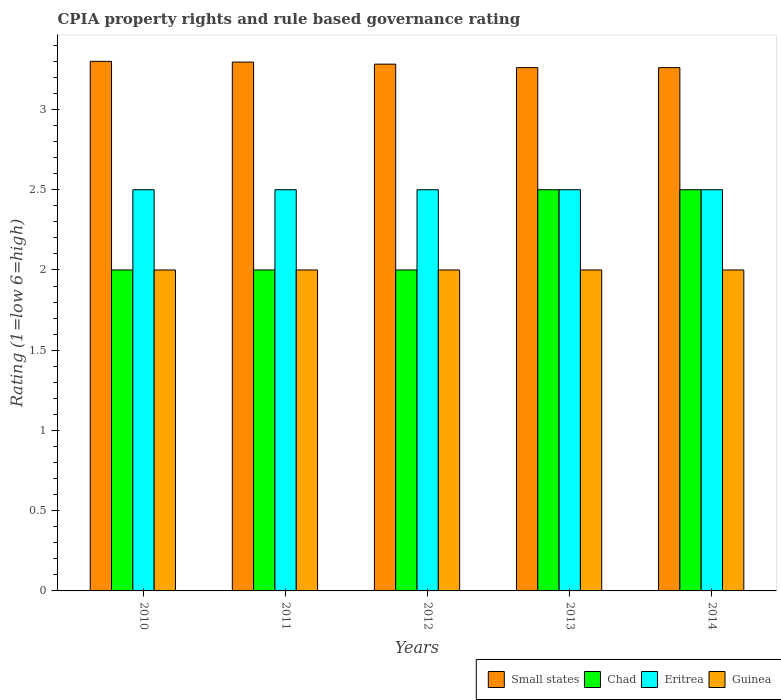How many groups of bars are there?
Your answer should be compact. 5. Are the number of bars per tick equal to the number of legend labels?
Give a very brief answer. Yes. Are the number of bars on each tick of the X-axis equal?
Keep it short and to the point. Yes. How many bars are there on the 1st tick from the right?
Ensure brevity in your answer.  4. What is the label of the 5th group of bars from the left?
Offer a very short reply. 2014. What is the CPIA rating in Small states in 2013?
Provide a succinct answer. 3.26. Across all years, what is the maximum CPIA rating in Guinea?
Provide a succinct answer. 2. In which year was the CPIA rating in Chad minimum?
Your answer should be very brief. 2010. What is the total CPIA rating in Small states in the graph?
Your response must be concise. 16.4. What is the difference between the CPIA rating in Eritrea in 2011 and that in 2013?
Provide a short and direct response. 0. In the year 2014, what is the difference between the CPIA rating in Guinea and CPIA rating in Small states?
Your answer should be compact. -1.26. Is the difference between the CPIA rating in Guinea in 2012 and 2013 greater than the difference between the CPIA rating in Small states in 2012 and 2013?
Offer a terse response. No. What is the difference between the highest and the lowest CPIA rating in Chad?
Offer a very short reply. 0.5. In how many years, is the CPIA rating in Guinea greater than the average CPIA rating in Guinea taken over all years?
Give a very brief answer. 0. Is the sum of the CPIA rating in Small states in 2012 and 2013 greater than the maximum CPIA rating in Eritrea across all years?
Keep it short and to the point. Yes. What does the 3rd bar from the left in 2012 represents?
Offer a terse response. Eritrea. What does the 1st bar from the right in 2014 represents?
Offer a very short reply. Guinea. Is it the case that in every year, the sum of the CPIA rating in Small states and CPIA rating in Eritrea is greater than the CPIA rating in Chad?
Your answer should be very brief. Yes. Does the graph contain any zero values?
Your answer should be compact. No. How many legend labels are there?
Offer a very short reply. 4. How are the legend labels stacked?
Give a very brief answer. Horizontal. What is the title of the graph?
Give a very brief answer. CPIA property rights and rule based governance rating. What is the label or title of the X-axis?
Make the answer very short. Years. What is the Rating (1=low 6=high) of Chad in 2010?
Offer a terse response. 2. What is the Rating (1=low 6=high) in Eritrea in 2010?
Provide a succinct answer. 2.5. What is the Rating (1=low 6=high) in Small states in 2011?
Offer a very short reply. 3.3. What is the Rating (1=low 6=high) in Guinea in 2011?
Provide a short and direct response. 2. What is the Rating (1=low 6=high) in Small states in 2012?
Provide a succinct answer. 3.28. What is the Rating (1=low 6=high) of Chad in 2012?
Keep it short and to the point. 2. What is the Rating (1=low 6=high) in Eritrea in 2012?
Make the answer very short. 2.5. What is the Rating (1=low 6=high) of Guinea in 2012?
Ensure brevity in your answer.  2. What is the Rating (1=low 6=high) of Small states in 2013?
Keep it short and to the point. 3.26. What is the Rating (1=low 6=high) of Eritrea in 2013?
Provide a succinct answer. 2.5. What is the Rating (1=low 6=high) in Small states in 2014?
Provide a succinct answer. 3.26. Across all years, what is the maximum Rating (1=low 6=high) of Small states?
Offer a very short reply. 3.3. Across all years, what is the maximum Rating (1=low 6=high) of Chad?
Ensure brevity in your answer.  2.5. Across all years, what is the maximum Rating (1=low 6=high) in Guinea?
Offer a very short reply. 2. Across all years, what is the minimum Rating (1=low 6=high) of Small states?
Your answer should be very brief. 3.26. Across all years, what is the minimum Rating (1=low 6=high) in Chad?
Ensure brevity in your answer.  2. Across all years, what is the minimum Rating (1=low 6=high) in Eritrea?
Offer a terse response. 2.5. Across all years, what is the minimum Rating (1=low 6=high) in Guinea?
Your answer should be very brief. 2. What is the total Rating (1=low 6=high) of Small states in the graph?
Give a very brief answer. 16.4. What is the total Rating (1=low 6=high) in Chad in the graph?
Your answer should be very brief. 11. What is the total Rating (1=low 6=high) in Eritrea in the graph?
Offer a terse response. 12.5. What is the difference between the Rating (1=low 6=high) in Small states in 2010 and that in 2011?
Provide a short and direct response. 0. What is the difference between the Rating (1=low 6=high) in Guinea in 2010 and that in 2011?
Give a very brief answer. 0. What is the difference between the Rating (1=low 6=high) of Small states in 2010 and that in 2012?
Your response must be concise. 0.02. What is the difference between the Rating (1=low 6=high) in Chad in 2010 and that in 2012?
Make the answer very short. 0. What is the difference between the Rating (1=low 6=high) of Guinea in 2010 and that in 2012?
Ensure brevity in your answer.  0. What is the difference between the Rating (1=low 6=high) of Small states in 2010 and that in 2013?
Offer a very short reply. 0.04. What is the difference between the Rating (1=low 6=high) of Guinea in 2010 and that in 2013?
Your answer should be compact. 0. What is the difference between the Rating (1=low 6=high) in Small states in 2010 and that in 2014?
Keep it short and to the point. 0.04. What is the difference between the Rating (1=low 6=high) of Guinea in 2010 and that in 2014?
Make the answer very short. 0. What is the difference between the Rating (1=low 6=high) of Small states in 2011 and that in 2012?
Give a very brief answer. 0.01. What is the difference between the Rating (1=low 6=high) in Eritrea in 2011 and that in 2012?
Keep it short and to the point. 0. What is the difference between the Rating (1=low 6=high) in Small states in 2011 and that in 2013?
Make the answer very short. 0.03. What is the difference between the Rating (1=low 6=high) of Guinea in 2011 and that in 2013?
Ensure brevity in your answer.  0. What is the difference between the Rating (1=low 6=high) of Small states in 2011 and that in 2014?
Offer a terse response. 0.03. What is the difference between the Rating (1=low 6=high) of Guinea in 2011 and that in 2014?
Your answer should be very brief. 0. What is the difference between the Rating (1=low 6=high) in Small states in 2012 and that in 2013?
Give a very brief answer. 0.02. What is the difference between the Rating (1=low 6=high) in Chad in 2012 and that in 2013?
Keep it short and to the point. -0.5. What is the difference between the Rating (1=low 6=high) in Guinea in 2012 and that in 2013?
Ensure brevity in your answer.  0. What is the difference between the Rating (1=low 6=high) in Small states in 2012 and that in 2014?
Offer a terse response. 0.02. What is the difference between the Rating (1=low 6=high) in Guinea in 2012 and that in 2014?
Provide a succinct answer. 0. What is the difference between the Rating (1=low 6=high) in Small states in 2013 and that in 2014?
Provide a succinct answer. 0. What is the difference between the Rating (1=low 6=high) in Eritrea in 2013 and that in 2014?
Provide a succinct answer. 0. What is the difference between the Rating (1=low 6=high) in Guinea in 2013 and that in 2014?
Make the answer very short. 0. What is the difference between the Rating (1=low 6=high) of Chad in 2010 and the Rating (1=low 6=high) of Eritrea in 2011?
Provide a short and direct response. -0.5. What is the difference between the Rating (1=low 6=high) of Chad in 2010 and the Rating (1=low 6=high) of Guinea in 2011?
Provide a succinct answer. 0. What is the difference between the Rating (1=low 6=high) in Eritrea in 2010 and the Rating (1=low 6=high) in Guinea in 2011?
Your answer should be very brief. 0.5. What is the difference between the Rating (1=low 6=high) of Small states in 2010 and the Rating (1=low 6=high) of Chad in 2012?
Give a very brief answer. 1.3. What is the difference between the Rating (1=low 6=high) in Small states in 2010 and the Rating (1=low 6=high) in Eritrea in 2013?
Keep it short and to the point. 0.8. What is the difference between the Rating (1=low 6=high) in Chad in 2010 and the Rating (1=low 6=high) in Eritrea in 2013?
Provide a short and direct response. -0.5. What is the difference between the Rating (1=low 6=high) of Chad in 2010 and the Rating (1=low 6=high) of Guinea in 2013?
Provide a succinct answer. 0. What is the difference between the Rating (1=low 6=high) of Eritrea in 2010 and the Rating (1=low 6=high) of Guinea in 2013?
Your answer should be very brief. 0.5. What is the difference between the Rating (1=low 6=high) of Small states in 2010 and the Rating (1=low 6=high) of Chad in 2014?
Your response must be concise. 0.8. What is the difference between the Rating (1=low 6=high) of Small states in 2010 and the Rating (1=low 6=high) of Guinea in 2014?
Give a very brief answer. 1.3. What is the difference between the Rating (1=low 6=high) in Chad in 2010 and the Rating (1=low 6=high) in Guinea in 2014?
Make the answer very short. 0. What is the difference between the Rating (1=low 6=high) of Small states in 2011 and the Rating (1=low 6=high) of Chad in 2012?
Your answer should be very brief. 1.3. What is the difference between the Rating (1=low 6=high) of Small states in 2011 and the Rating (1=low 6=high) of Eritrea in 2012?
Offer a very short reply. 0.8. What is the difference between the Rating (1=low 6=high) of Small states in 2011 and the Rating (1=low 6=high) of Guinea in 2012?
Offer a very short reply. 1.3. What is the difference between the Rating (1=low 6=high) in Chad in 2011 and the Rating (1=low 6=high) in Eritrea in 2012?
Your response must be concise. -0.5. What is the difference between the Rating (1=low 6=high) of Chad in 2011 and the Rating (1=low 6=high) of Guinea in 2012?
Your answer should be very brief. 0. What is the difference between the Rating (1=low 6=high) in Small states in 2011 and the Rating (1=low 6=high) in Chad in 2013?
Offer a very short reply. 0.8. What is the difference between the Rating (1=low 6=high) of Small states in 2011 and the Rating (1=low 6=high) of Eritrea in 2013?
Make the answer very short. 0.8. What is the difference between the Rating (1=low 6=high) in Small states in 2011 and the Rating (1=low 6=high) in Guinea in 2013?
Ensure brevity in your answer.  1.3. What is the difference between the Rating (1=low 6=high) in Small states in 2011 and the Rating (1=low 6=high) in Chad in 2014?
Provide a succinct answer. 0.8. What is the difference between the Rating (1=low 6=high) of Small states in 2011 and the Rating (1=low 6=high) of Eritrea in 2014?
Provide a succinct answer. 0.8. What is the difference between the Rating (1=low 6=high) in Small states in 2011 and the Rating (1=low 6=high) in Guinea in 2014?
Offer a very short reply. 1.3. What is the difference between the Rating (1=low 6=high) of Eritrea in 2011 and the Rating (1=low 6=high) of Guinea in 2014?
Make the answer very short. 0.5. What is the difference between the Rating (1=low 6=high) in Small states in 2012 and the Rating (1=low 6=high) in Chad in 2013?
Provide a short and direct response. 0.78. What is the difference between the Rating (1=low 6=high) in Small states in 2012 and the Rating (1=low 6=high) in Eritrea in 2013?
Offer a very short reply. 0.78. What is the difference between the Rating (1=low 6=high) in Small states in 2012 and the Rating (1=low 6=high) in Guinea in 2013?
Keep it short and to the point. 1.28. What is the difference between the Rating (1=low 6=high) in Chad in 2012 and the Rating (1=low 6=high) in Eritrea in 2013?
Make the answer very short. -0.5. What is the difference between the Rating (1=low 6=high) in Chad in 2012 and the Rating (1=low 6=high) in Guinea in 2013?
Offer a terse response. 0. What is the difference between the Rating (1=low 6=high) in Small states in 2012 and the Rating (1=low 6=high) in Chad in 2014?
Ensure brevity in your answer.  0.78. What is the difference between the Rating (1=low 6=high) of Small states in 2012 and the Rating (1=low 6=high) of Eritrea in 2014?
Give a very brief answer. 0.78. What is the difference between the Rating (1=low 6=high) of Small states in 2012 and the Rating (1=low 6=high) of Guinea in 2014?
Your answer should be very brief. 1.28. What is the difference between the Rating (1=low 6=high) in Chad in 2012 and the Rating (1=low 6=high) in Guinea in 2014?
Provide a succinct answer. 0. What is the difference between the Rating (1=low 6=high) in Eritrea in 2012 and the Rating (1=low 6=high) in Guinea in 2014?
Make the answer very short. 0.5. What is the difference between the Rating (1=low 6=high) of Small states in 2013 and the Rating (1=low 6=high) of Chad in 2014?
Offer a very short reply. 0.76. What is the difference between the Rating (1=low 6=high) in Small states in 2013 and the Rating (1=low 6=high) in Eritrea in 2014?
Your answer should be very brief. 0.76. What is the difference between the Rating (1=low 6=high) of Small states in 2013 and the Rating (1=low 6=high) of Guinea in 2014?
Your response must be concise. 1.26. What is the difference between the Rating (1=low 6=high) of Chad in 2013 and the Rating (1=low 6=high) of Guinea in 2014?
Your answer should be compact. 0.5. What is the difference between the Rating (1=low 6=high) of Eritrea in 2013 and the Rating (1=low 6=high) of Guinea in 2014?
Make the answer very short. 0.5. What is the average Rating (1=low 6=high) in Small states per year?
Offer a terse response. 3.28. What is the average Rating (1=low 6=high) in Eritrea per year?
Your answer should be very brief. 2.5. In the year 2010, what is the difference between the Rating (1=low 6=high) in Small states and Rating (1=low 6=high) in Chad?
Make the answer very short. 1.3. In the year 2010, what is the difference between the Rating (1=low 6=high) of Small states and Rating (1=low 6=high) of Eritrea?
Offer a terse response. 0.8. In the year 2010, what is the difference between the Rating (1=low 6=high) in Small states and Rating (1=low 6=high) in Guinea?
Your answer should be compact. 1.3. In the year 2010, what is the difference between the Rating (1=low 6=high) of Chad and Rating (1=low 6=high) of Eritrea?
Offer a very short reply. -0.5. In the year 2010, what is the difference between the Rating (1=low 6=high) in Chad and Rating (1=low 6=high) in Guinea?
Offer a very short reply. 0. In the year 2011, what is the difference between the Rating (1=low 6=high) of Small states and Rating (1=low 6=high) of Chad?
Keep it short and to the point. 1.3. In the year 2011, what is the difference between the Rating (1=low 6=high) in Small states and Rating (1=low 6=high) in Eritrea?
Provide a succinct answer. 0.8. In the year 2011, what is the difference between the Rating (1=low 6=high) of Small states and Rating (1=low 6=high) of Guinea?
Provide a short and direct response. 1.3. In the year 2011, what is the difference between the Rating (1=low 6=high) in Chad and Rating (1=low 6=high) in Eritrea?
Provide a short and direct response. -0.5. In the year 2012, what is the difference between the Rating (1=low 6=high) in Small states and Rating (1=low 6=high) in Chad?
Provide a short and direct response. 1.28. In the year 2012, what is the difference between the Rating (1=low 6=high) of Small states and Rating (1=low 6=high) of Eritrea?
Your answer should be compact. 0.78. In the year 2012, what is the difference between the Rating (1=low 6=high) in Small states and Rating (1=low 6=high) in Guinea?
Your answer should be compact. 1.28. In the year 2012, what is the difference between the Rating (1=low 6=high) in Eritrea and Rating (1=low 6=high) in Guinea?
Provide a short and direct response. 0.5. In the year 2013, what is the difference between the Rating (1=low 6=high) of Small states and Rating (1=low 6=high) of Chad?
Your response must be concise. 0.76. In the year 2013, what is the difference between the Rating (1=low 6=high) of Small states and Rating (1=low 6=high) of Eritrea?
Keep it short and to the point. 0.76. In the year 2013, what is the difference between the Rating (1=low 6=high) of Small states and Rating (1=low 6=high) of Guinea?
Give a very brief answer. 1.26. In the year 2013, what is the difference between the Rating (1=low 6=high) in Chad and Rating (1=low 6=high) in Guinea?
Give a very brief answer. 0.5. In the year 2013, what is the difference between the Rating (1=low 6=high) of Eritrea and Rating (1=low 6=high) of Guinea?
Keep it short and to the point. 0.5. In the year 2014, what is the difference between the Rating (1=low 6=high) in Small states and Rating (1=low 6=high) in Chad?
Your answer should be compact. 0.76. In the year 2014, what is the difference between the Rating (1=low 6=high) of Small states and Rating (1=low 6=high) of Eritrea?
Your answer should be compact. 0.76. In the year 2014, what is the difference between the Rating (1=low 6=high) of Small states and Rating (1=low 6=high) of Guinea?
Keep it short and to the point. 1.26. In the year 2014, what is the difference between the Rating (1=low 6=high) of Chad and Rating (1=low 6=high) of Eritrea?
Give a very brief answer. 0. In the year 2014, what is the difference between the Rating (1=low 6=high) in Eritrea and Rating (1=low 6=high) in Guinea?
Provide a short and direct response. 0.5. What is the ratio of the Rating (1=low 6=high) in Eritrea in 2010 to that in 2011?
Ensure brevity in your answer.  1. What is the ratio of the Rating (1=low 6=high) of Guinea in 2010 to that in 2011?
Your answer should be compact. 1. What is the ratio of the Rating (1=low 6=high) of Guinea in 2010 to that in 2012?
Keep it short and to the point. 1. What is the ratio of the Rating (1=low 6=high) of Small states in 2010 to that in 2013?
Your answer should be very brief. 1.01. What is the ratio of the Rating (1=low 6=high) in Chad in 2010 to that in 2013?
Give a very brief answer. 0.8. What is the ratio of the Rating (1=low 6=high) in Guinea in 2010 to that in 2013?
Give a very brief answer. 1. What is the ratio of the Rating (1=low 6=high) of Small states in 2010 to that in 2014?
Make the answer very short. 1.01. What is the ratio of the Rating (1=low 6=high) in Eritrea in 2010 to that in 2014?
Ensure brevity in your answer.  1. What is the ratio of the Rating (1=low 6=high) in Guinea in 2010 to that in 2014?
Provide a succinct answer. 1. What is the ratio of the Rating (1=low 6=high) of Small states in 2011 to that in 2012?
Provide a short and direct response. 1. What is the ratio of the Rating (1=low 6=high) of Eritrea in 2011 to that in 2012?
Offer a terse response. 1. What is the ratio of the Rating (1=low 6=high) of Guinea in 2011 to that in 2012?
Your answer should be compact. 1. What is the ratio of the Rating (1=low 6=high) of Small states in 2011 to that in 2013?
Ensure brevity in your answer.  1.01. What is the ratio of the Rating (1=low 6=high) in Eritrea in 2011 to that in 2013?
Your answer should be compact. 1. What is the ratio of the Rating (1=low 6=high) in Guinea in 2011 to that in 2013?
Give a very brief answer. 1. What is the ratio of the Rating (1=low 6=high) of Small states in 2011 to that in 2014?
Provide a short and direct response. 1.01. What is the ratio of the Rating (1=low 6=high) of Chad in 2011 to that in 2014?
Offer a very short reply. 0.8. What is the ratio of the Rating (1=low 6=high) in Eritrea in 2011 to that in 2014?
Your response must be concise. 1. What is the ratio of the Rating (1=low 6=high) of Small states in 2012 to that in 2013?
Give a very brief answer. 1.01. What is the ratio of the Rating (1=low 6=high) in Eritrea in 2012 to that in 2013?
Your answer should be compact. 1. What is the ratio of the Rating (1=low 6=high) in Guinea in 2012 to that in 2013?
Offer a terse response. 1. What is the ratio of the Rating (1=low 6=high) in Eritrea in 2012 to that in 2014?
Offer a very short reply. 1. What is the ratio of the Rating (1=low 6=high) in Guinea in 2012 to that in 2014?
Ensure brevity in your answer.  1. What is the ratio of the Rating (1=low 6=high) of Small states in 2013 to that in 2014?
Provide a succinct answer. 1. What is the ratio of the Rating (1=low 6=high) of Eritrea in 2013 to that in 2014?
Your answer should be very brief. 1. What is the ratio of the Rating (1=low 6=high) in Guinea in 2013 to that in 2014?
Keep it short and to the point. 1. What is the difference between the highest and the second highest Rating (1=low 6=high) of Small states?
Ensure brevity in your answer.  0. What is the difference between the highest and the lowest Rating (1=low 6=high) of Small states?
Give a very brief answer. 0.04. 